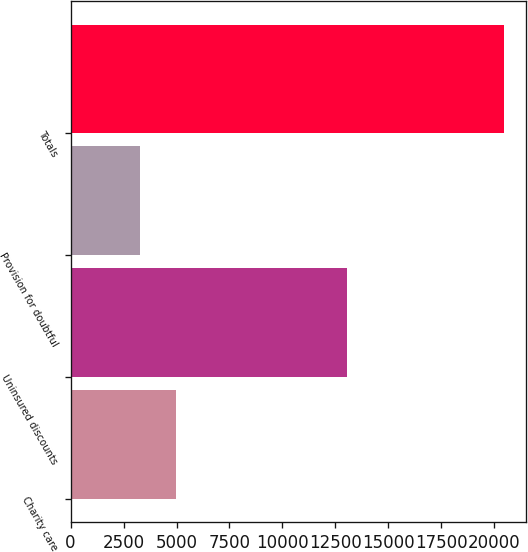Convert chart. <chart><loc_0><loc_0><loc_500><loc_500><bar_chart><fcel>Charity care<fcel>Uninsured discounts<fcel>Provision for doubtful<fcel>Totals<nl><fcel>4976.8<fcel>13047<fcel>3257<fcel>20455<nl></chart> 